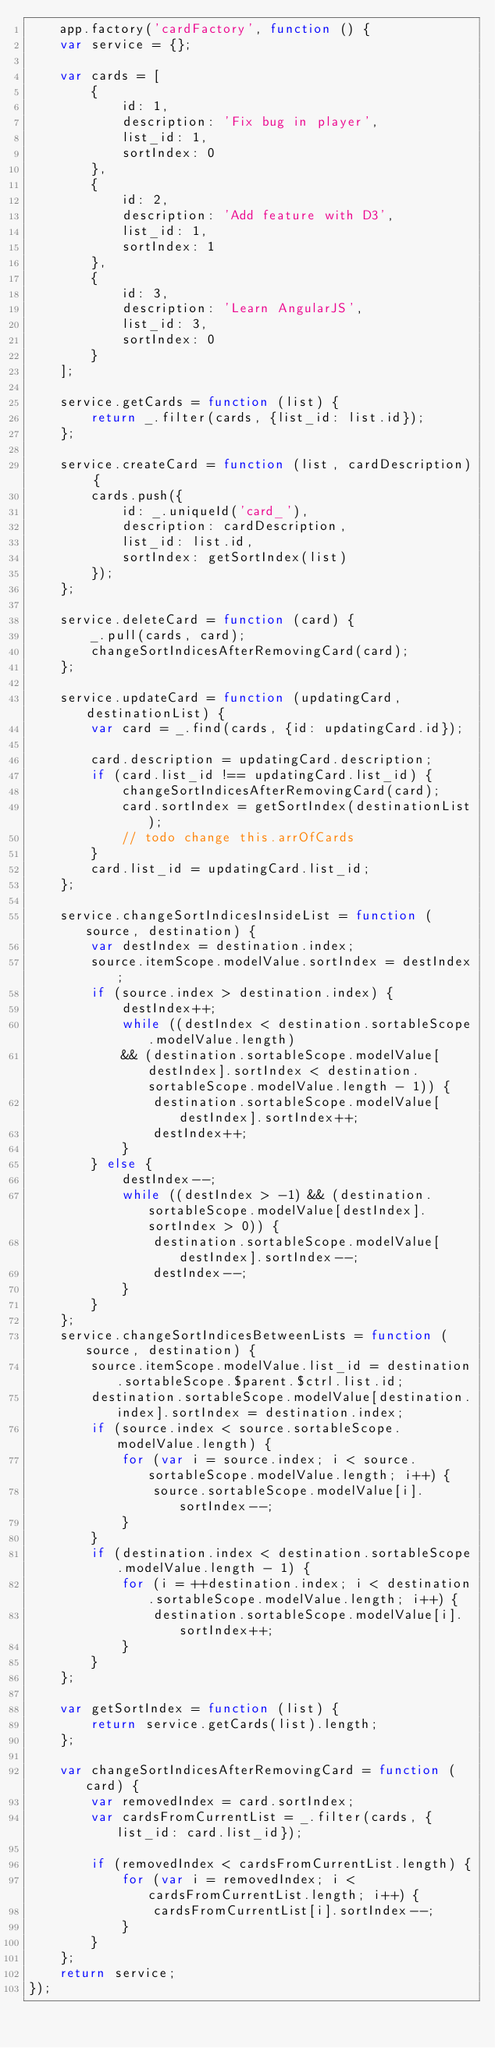Convert code to text. <code><loc_0><loc_0><loc_500><loc_500><_JavaScript_>    app.factory('cardFactory', function () {
    var service = {};

    var cards = [
        {
            id: 1,
            description: 'Fix bug in player',
            list_id: 1,
            sortIndex: 0
        },
        {
            id: 2,
            description: 'Add feature with D3',
            list_id: 1,
            sortIndex: 1
        },
        {
            id: 3,
            description: 'Learn AngularJS',
            list_id: 3,
            sortIndex: 0
        }
    ];

    service.getCards = function (list) {
        return _.filter(cards, {list_id: list.id});
    };

    service.createCard = function (list, cardDescription) {
        cards.push({
            id: _.uniqueId('card_'),
            description: cardDescription,
            list_id: list.id,
            sortIndex: getSortIndex(list)
        });
    };

    service.deleteCard = function (card) {
        _.pull(cards, card);
        changeSortIndicesAfterRemovingCard(card);
    };

    service.updateCard = function (updatingCard, destinationList) {
        var card = _.find(cards, {id: updatingCard.id});

        card.description = updatingCard.description;
        if (card.list_id !== updatingCard.list_id) {
            changeSortIndicesAfterRemovingCard(card);
            card.sortIndex = getSortIndex(destinationList);
            // todo change this.arrOfCards
        }
        card.list_id = updatingCard.list_id;
    };

    service.changeSortIndicesInsideList = function (source, destination) {
        var destIndex = destination.index;
        source.itemScope.modelValue.sortIndex = destIndex;
        if (source.index > destination.index) {
            destIndex++;
            while ((destIndex < destination.sortableScope.modelValue.length)
            && (destination.sortableScope.modelValue[destIndex].sortIndex < destination.sortableScope.modelValue.length - 1)) {
                destination.sortableScope.modelValue[destIndex].sortIndex++;
                destIndex++;
            }
        } else {
            destIndex--;
            while ((destIndex > -1) && (destination.sortableScope.modelValue[destIndex].sortIndex > 0)) {
                destination.sortableScope.modelValue[destIndex].sortIndex--;
                destIndex--;
            }
        }
    };
    service.changeSortIndicesBetweenLists = function (source, destination) {
        source.itemScope.modelValue.list_id = destination.sortableScope.$parent.$ctrl.list.id;
        destination.sortableScope.modelValue[destination.index].sortIndex = destination.index;
        if (source.index < source.sortableScope.modelValue.length) {
            for (var i = source.index; i < source.sortableScope.modelValue.length; i++) {
                source.sortableScope.modelValue[i].sortIndex--;
            }
        }
        if (destination.index < destination.sortableScope.modelValue.length - 1) {
            for (i = ++destination.index; i < destination.sortableScope.modelValue.length; i++) {
                destination.sortableScope.modelValue[i].sortIndex++;
            }
        }
    };

    var getSortIndex = function (list) {
        return service.getCards(list).length;
    };

    var changeSortIndicesAfterRemovingCard = function (card) {
        var removedIndex = card.sortIndex;
        var cardsFromCurrentList = _.filter(cards, {list_id: card.list_id});

        if (removedIndex < cardsFromCurrentList.length) {
            for (var i = removedIndex; i < cardsFromCurrentList.length; i++) {
                cardsFromCurrentList[i].sortIndex--;
            }
        }
    };
    return service;
});
</code> 